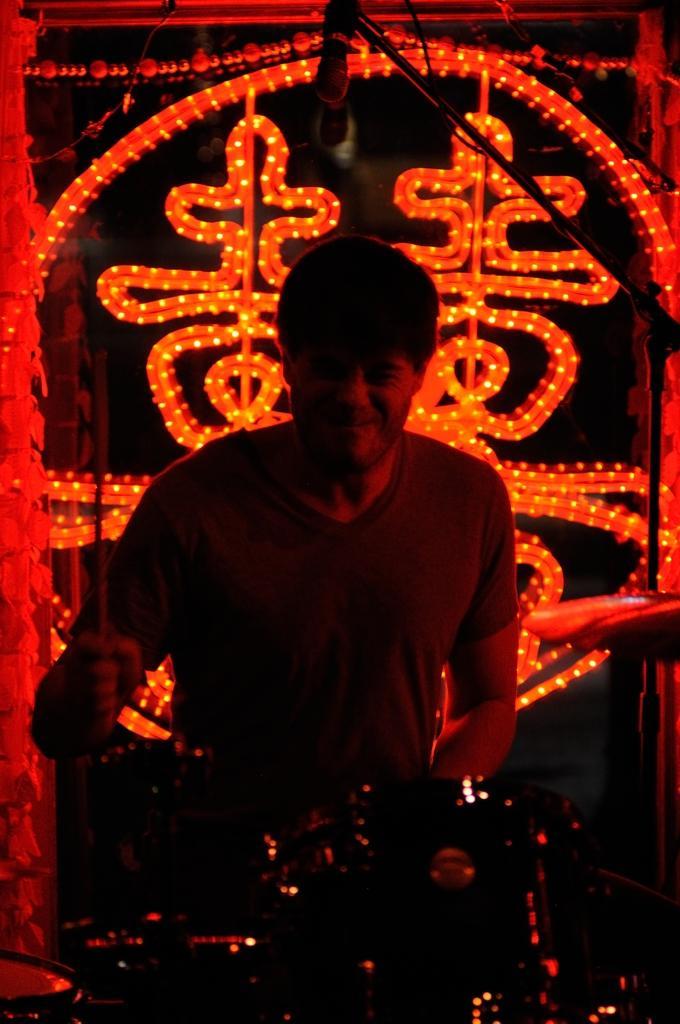Could you give a brief overview of what you see in this image? In this image in the front there is a musical instrument. In the center there is a person standing and holding stick in his hand and having some expression on his face and there is a mic and stand. In the background there lights. 